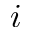Convert formula to latex. <formula><loc_0><loc_0><loc_500><loc_500>i</formula> 